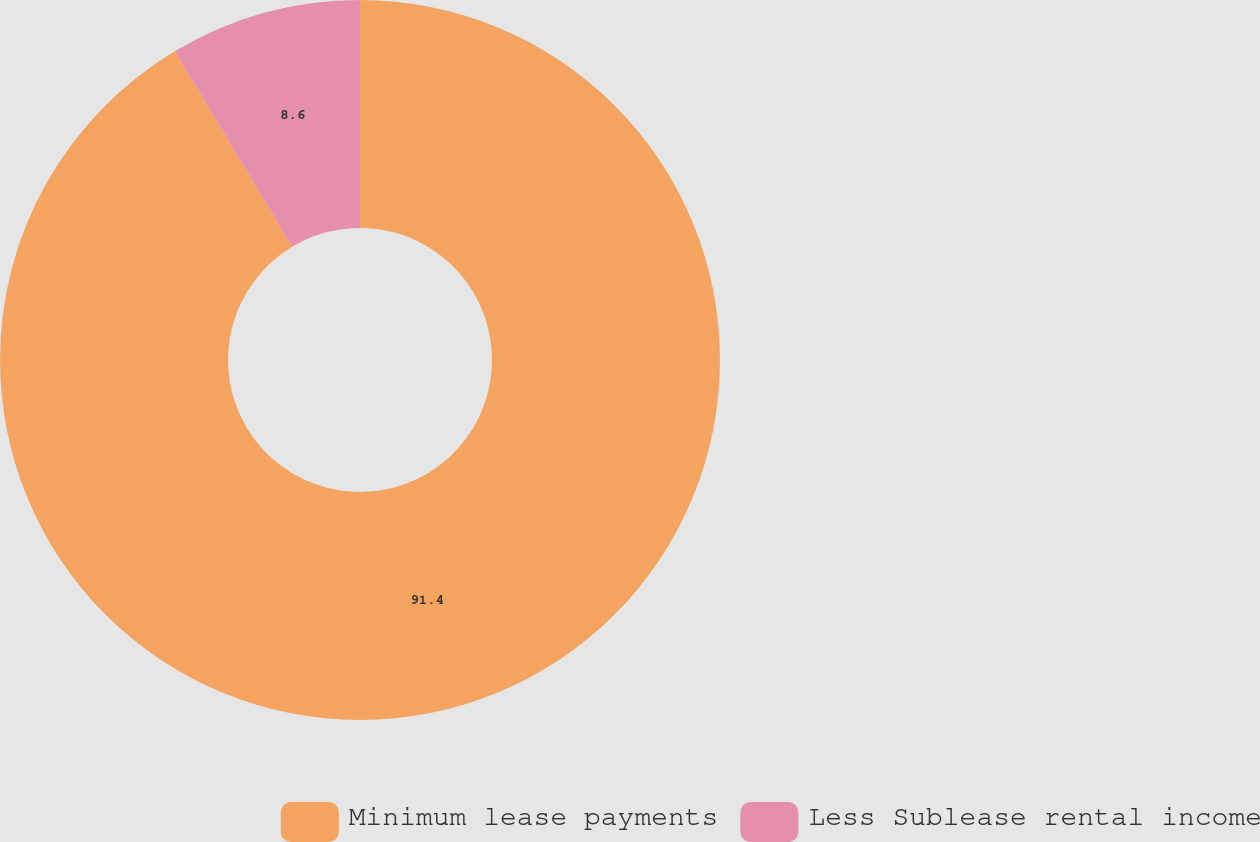Convert chart. <chart><loc_0><loc_0><loc_500><loc_500><pie_chart><fcel>Minimum lease payments<fcel>Less Sublease rental income<nl><fcel>91.4%<fcel>8.6%<nl></chart> 